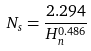Convert formula to latex. <formula><loc_0><loc_0><loc_500><loc_500>N _ { s } = \frac { 2 . 2 9 4 } { H _ { n } ^ { 0 . 4 8 6 } }</formula> 